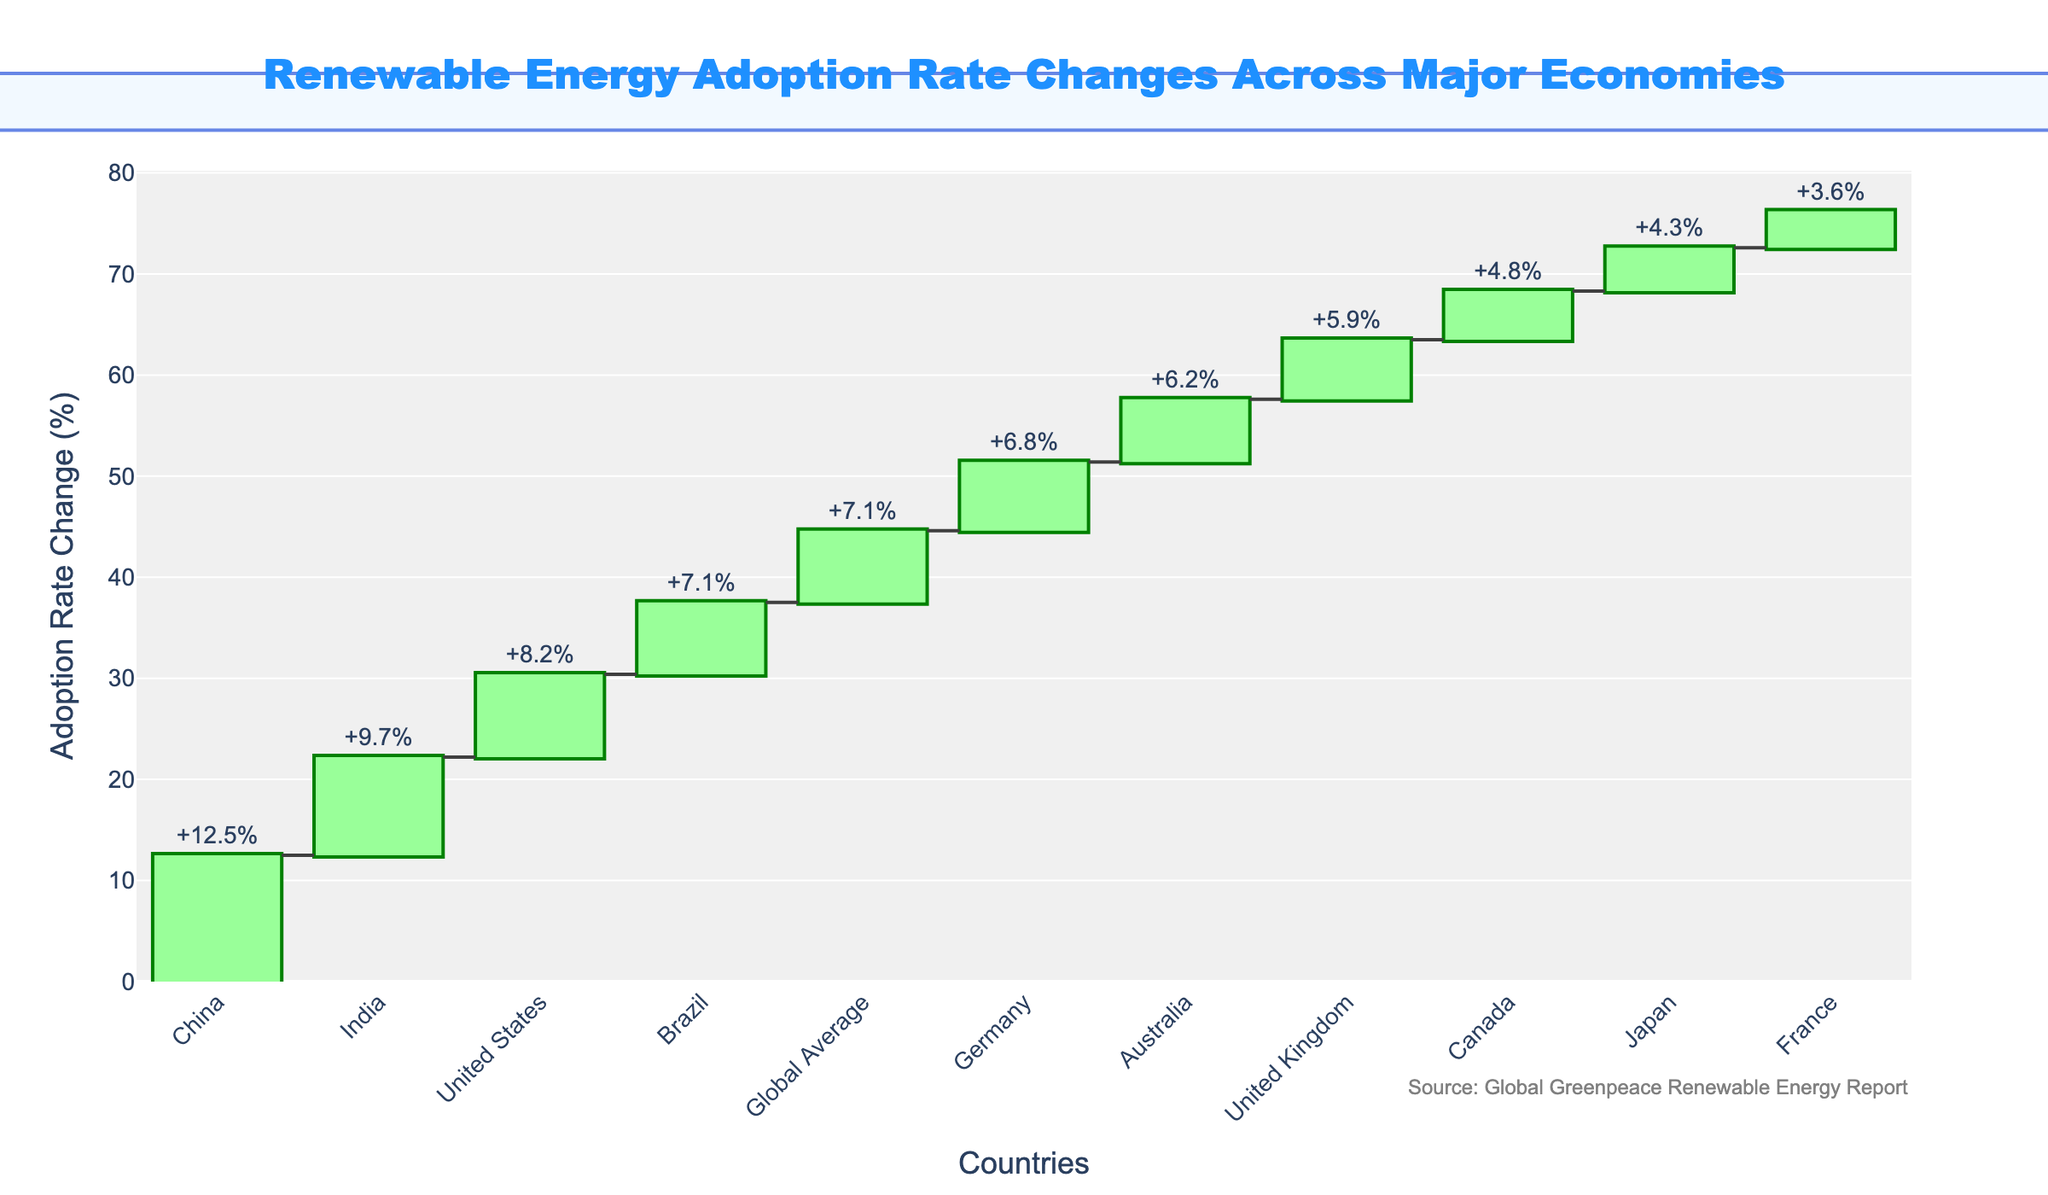What is the title of the waterfall chart? The title is located at the top center of the chart. It reads "Renewable Energy Adoption Rate Changes Across Major Economies" in bold blue text. The title directly indicates what the chart is about.
Answer: Renewable Energy Adoption Rate Changes Across Major Economies Which country has the highest renewable energy adoption rate change? To find the country with the highest adoption rate change, look for the bar with the highest positive value. The tallest green bar represents China, which has a +12.5% adoption rate change.
Answer: China What is the renewable energy adoption rate change for the United States? Locate the bar for the United States on the x-axis. The green bar with the corresponding text label shows a change of +8.2%.
Answer: +8.2% How many countries have a renewable energy adoption rate change greater than the global average of +7.1%? Identify countries with bars exceeding the horizontal line at +7.1%. These countries are China (+12.5%), India (+9.7%), the United States (+8.2%), and Brazil (+7.1%). Count these bars to find there are four countries.
Answer: 4 Which country has the lowest adoption rate change, and what is the value? Look for the bar with the lowest positive value. This is France, with a renewable energy adoption rate change of +3.6%.
Answer: France, +3.6% What is the cumulative adoption rate change after the first three countries? Look at the cumulative values for the first three countries (China, India, and the United States). Cumulative for China is +12.5%, for India it's 12.5% + 9.7% = 22.2%, and for the U.S., it's 22.2% + 8.2% = 30.4%.
Answer: +30.4% Which two countries have adoption rate changes closest to the global average? Compare each country's rate change with the global average of +7.1%. The countries closest to this value are Brazil (+7.1%) and Australia (+6.2%). The difference for Brazil is 0%, and for Australia, it is -0.9%.
Answer: Brazil and Australia How much higher is China's adoption rate change compared to France? Subtract the adoption rate change of France (+3.6%) from China (+12.5%). This gives 12.5% - 3.6% = 8.9%.
Answer: 8.9% What is the range of adoption rate changes among all countries? Determine the highest and lowest values. The highest is +12.5% (China) and the lowest is +3.6% (France). The range is obtained by subtracting the lowest from the highest, 12.5% - 3.6% = 8.9%.
Answer: 8.9% Which country’s adoption rate change is directly above Canada’s? Find the position of Canada's bar (+4.8%), and look for the country immediately before Canada in the sorted order. It is Japan with +4.3%.
Answer: Japan 